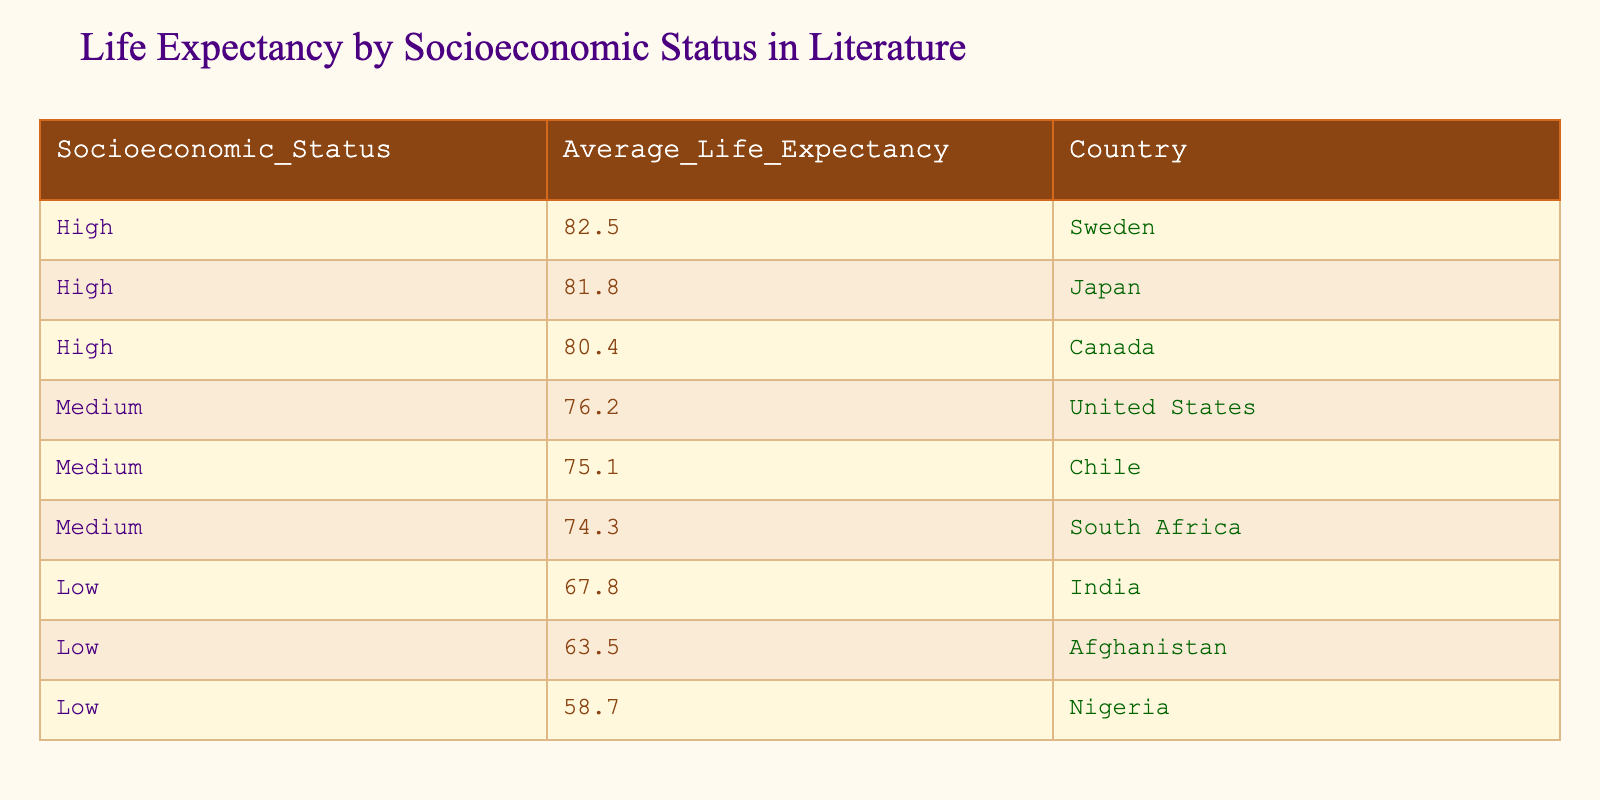What is the average life expectancy in high socioeconomic status countries? There are three countries listed under high socioeconomic status: Sweden (82.5), Japan (81.8), and Canada (80.4). To find the average, we sum these values: 82.5 + 81.8 + 80.4 = 244.7, and then divide by the number of countries (3). So, the average is 244.7 / 3 = 81.57.
Answer: 81.57 Which country has the lowest life expectancy among all listed? The lowest value from the life expectancy column is Nigeria with 58.7. Therefore, Nigeria has the lowest life expectancy among the countries listed.
Answer: Nigeria Is the life expectancy in the United States higher than in South Africa? The life expectancy in the United States is 76.2, while in South Africa it's 74.3. Since 76.2 is greater than 74.3, the statement is true.
Answer: Yes How many countries have a life expectancy below 70? Only two countries have a life expectancy below 70: India (67.8) and Nigeria (58.7). Thus, there are two countries in this category.
Answer: 2 What is the difference in average life expectancy between high and low socioeconomic status? The average life expectancy for high status is calculated as earlier: (82.5 + 81.8 + 80.4) / 3 = 81.57. For low status, calculate: (67.8 + 63.5 + 58.7) / 3 = 63.33. The difference is then 81.57 - 63.33 = 18.24.
Answer: 18.24 Are there more countries in the medium socioeconomic category than in the low socioeconomic category? The medium category has three countries (United States, Chile, and South Africa), and the low category also has three (India, Afghanistan, and Nigeria). Therefore, there are not more countries in the medium category than in the low category; they are equal.
Answer: No Which socioeconomic status category has the highest average life expectancy? Calculating the averages: High: 81.57, Medium: (76.2 + 75.1 + 74.3) / 3 = 75.53, Low: 63.33. Since 81.57 is the highest of these averages, high socioeconomic status has the highest average life expectancy.
Answer: High Which country has a life expectancy very close to the overall average of the medium socioeconomic group? The average life expectancy for the medium group is 75.53. The life expectancy for the United States is 76.2, which is closest to 75.53 when compared with the other medium countries.
Answer: United States What is the total life expectancy of all countries listed? We sum all the life expectancies: 82.5 + 81.8 + 80.4 + 76.2 + 75.1 + 74.3 + 67.8 + 63.5 + 58.7. The total equals 600.
Answer: 600 